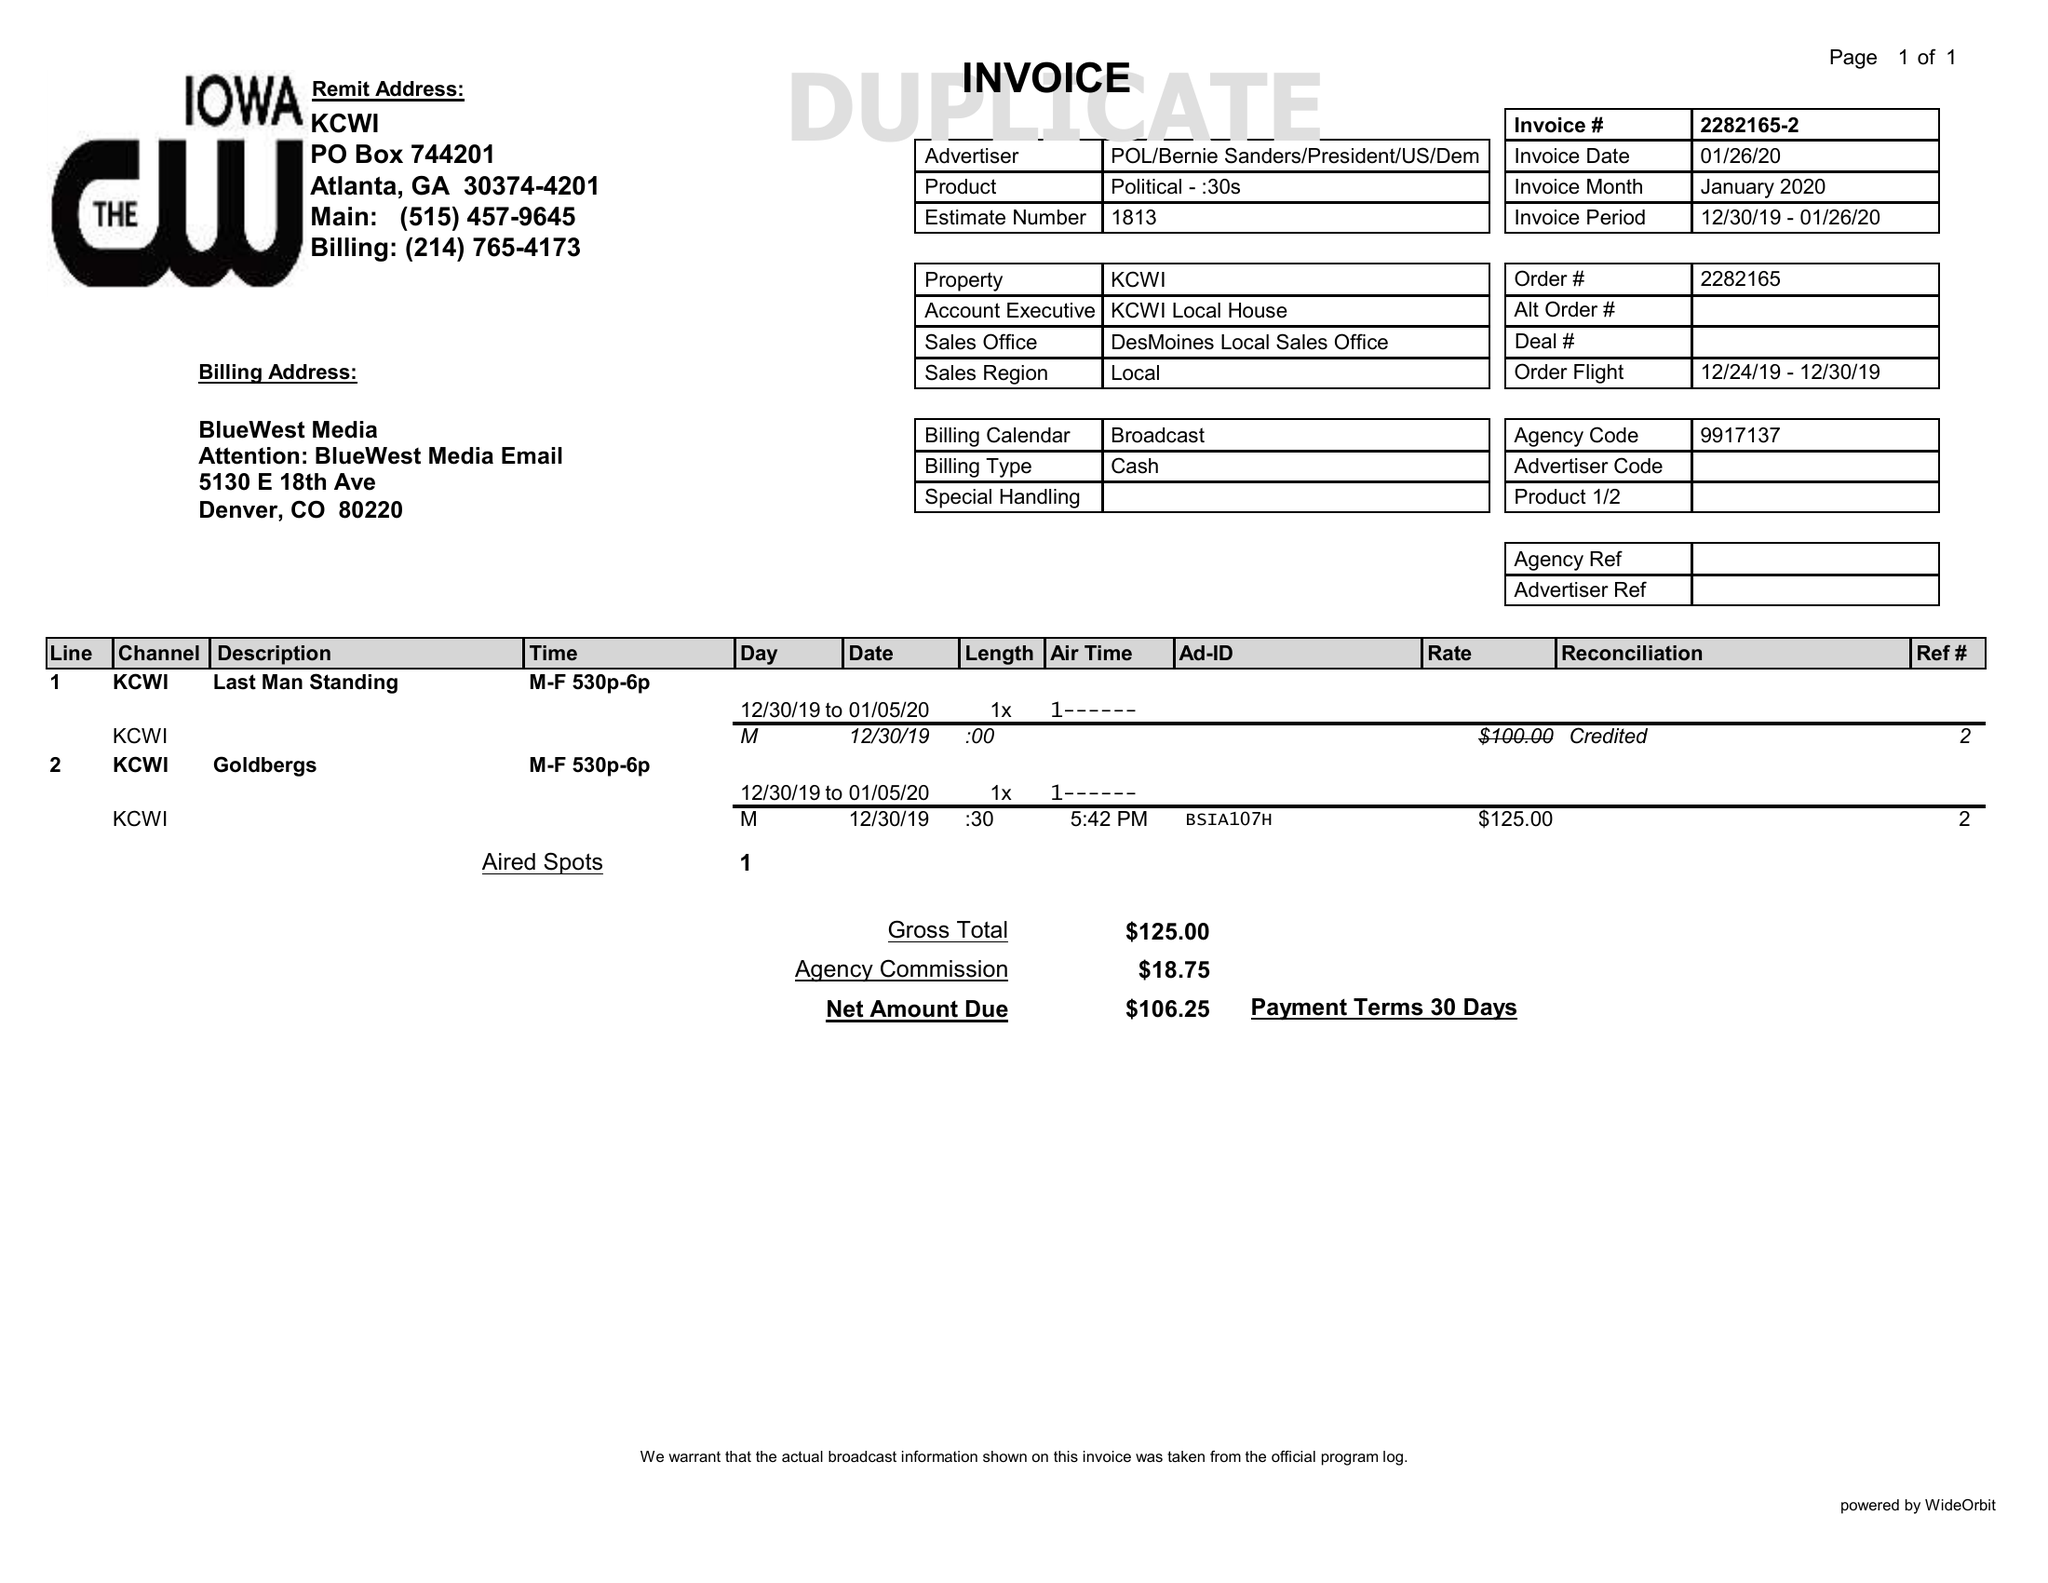What is the value for the advertiser?
Answer the question using a single word or phrase. POL/BERNIESANDERS/PRESIDENT/US/DEM 